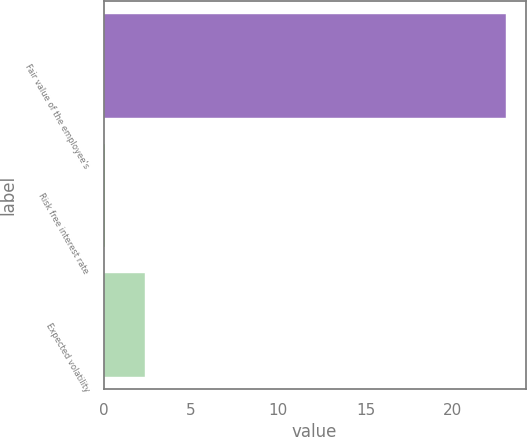Convert chart. <chart><loc_0><loc_0><loc_500><loc_500><bar_chart><fcel>Fair value of the employee's<fcel>Risk free interest rate<fcel>Expected volatility<nl><fcel>23.02<fcel>0.1<fcel>2.39<nl></chart> 